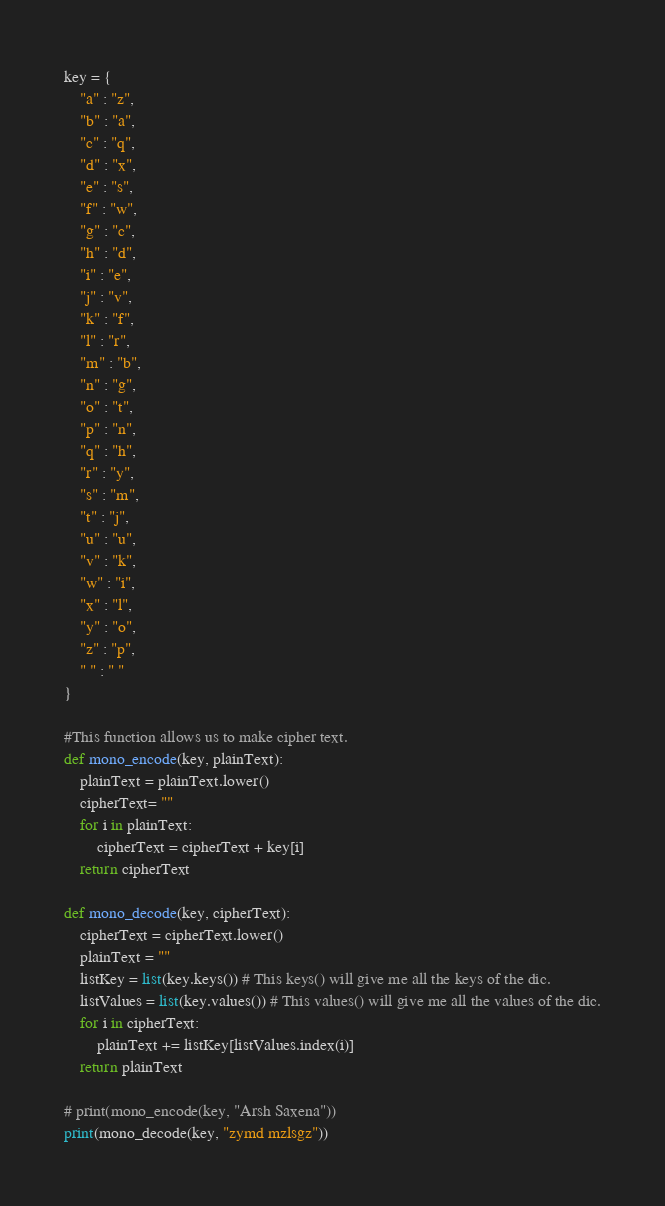<code> <loc_0><loc_0><loc_500><loc_500><_Python_>key = { 
    "a" : "z", 
    "b" : "a", 
    "c" : "q", 
    "d" : "x", 
    "e" : "s", 
    "f" : "w", 
    "g" : "c", 
    "h" : "d", 
    "i" : "e", 
    "j" : "v", 
    "k" : "f", 
    "l" : "r", 
    "m" : "b", 
    "n" : "g", 
    "o" : "t", 
    "p" : "n", 
    "q" : "h", 
    "r" : "y", 
    "s" : "m", 
    "t" : "j", 
    "u" : "u", 
    "v" : "k", 
    "w" : "i", 
    "x" : "l", 
    "y" : "o", 
    "z" : "p", 
    " " : " " 
}

#This function allows us to make cipher text.
def mono_encode(key, plainText):
    plainText = plainText.lower()
    cipherText= ""
    for i in plainText:
        cipherText = cipherText + key[i]
    return cipherText

def mono_decode(key, cipherText):
    cipherText = cipherText.lower()
    plainText = ""
    listKey = list(key.keys()) # This keys() will give me all the keys of the dic.
    listValues = list(key.values()) # This values() will give me all the values of the dic.
    for i in cipherText:
        plainText += listKey[listValues.index(i)]
    return plainText

# print(mono_encode(key, "Arsh Saxena"))
print(mono_decode(key, "zymd mzlsgz"))</code> 